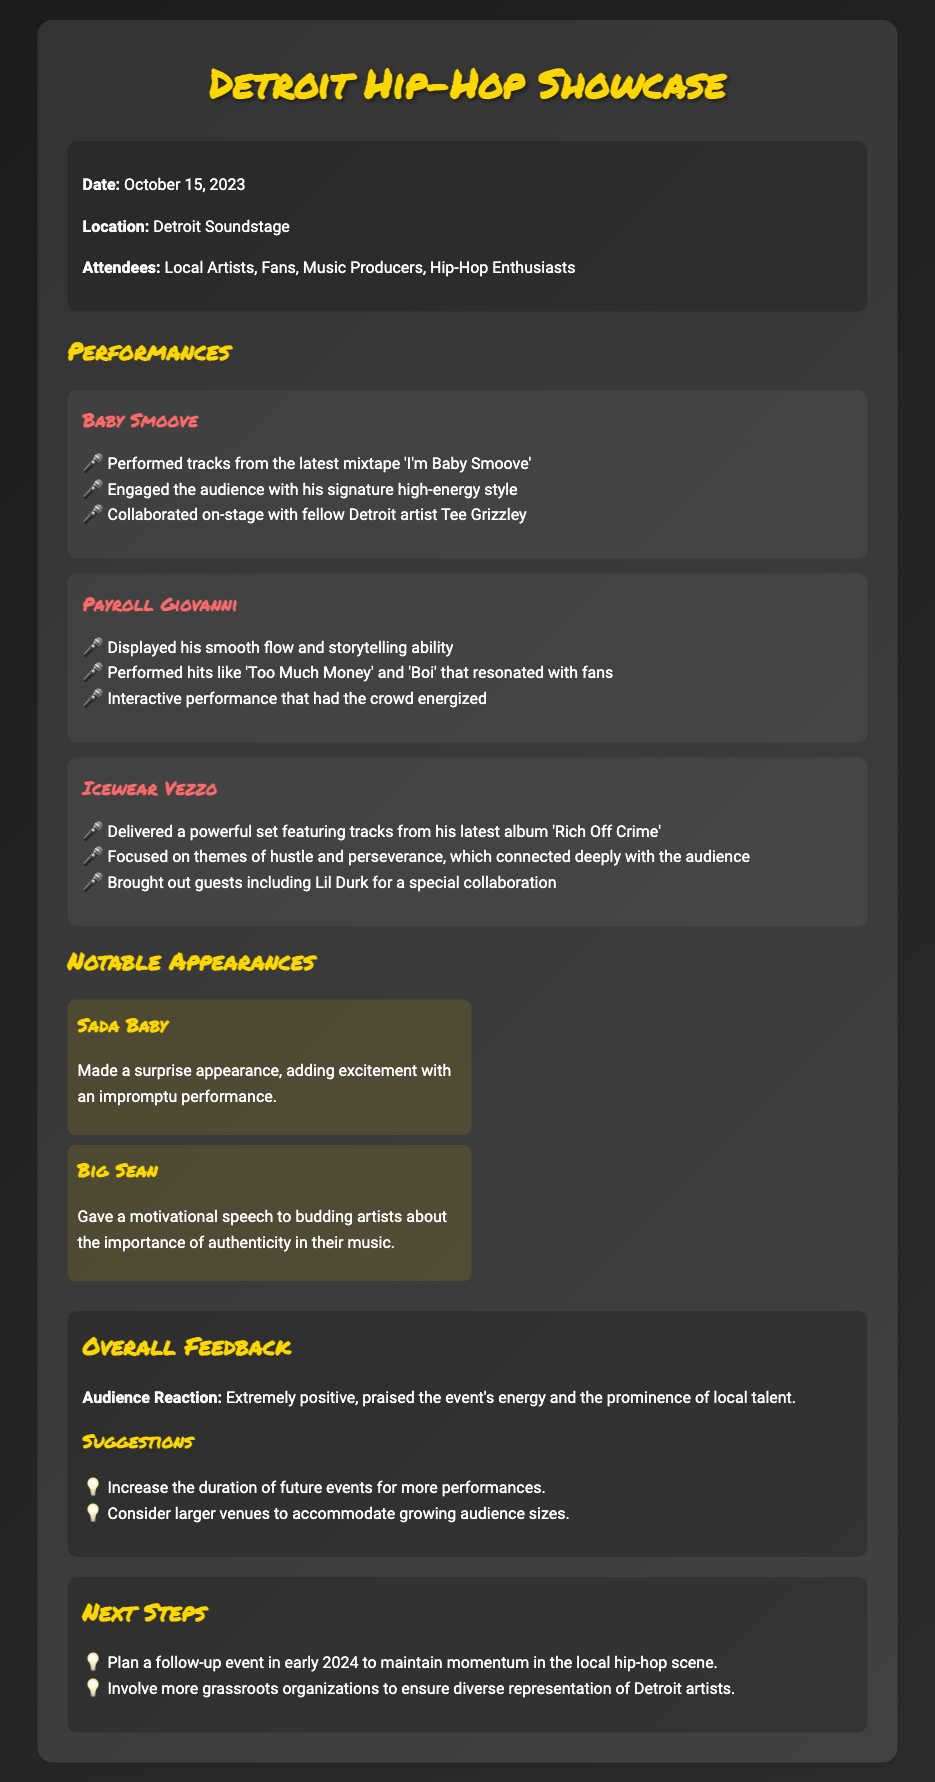What is the date of the event? The date of the event is explicitly mentioned in the document.
Answer: October 15, 2023 Who performed alongside Baby Smoove on stage? The document notes that Baby Smoove collaborated with another artist during his performance.
Answer: Tee Grizzley What track did Payroll Giovanni perform that resonated with fans? The document lists specific tracks performed by Payroll Giovanni that connected with the audience.
Answer: Too Much Money Which artist made a surprise appearance? The document highlights a notable unexpected artist at the event.
Answer: Sada Baby What was the audience reaction to the event? The document provides a summary of the feedback received from the audience about the showcase.
Answer: Extremely positive What is one suggestion for future events? The document mentions feedback gathered from the audience regarding potential improvements.
Answer: Increase the duration of future events for more performances What themes did Icewear Vezzo focus on during his performance? The document describes the themes presented during Icewear Vezzo's set.
Answer: Hustle and perseverance What motivational speech did Big Sean give? The document indicates the topic of the speech given by Big Sean to the audience.
Answer: Importance of authenticity in their music What is one of the next steps mentioned in the document? The document lays out the plans for follow-up actions after the event.
Answer: Plan a follow-up event in early 2024 